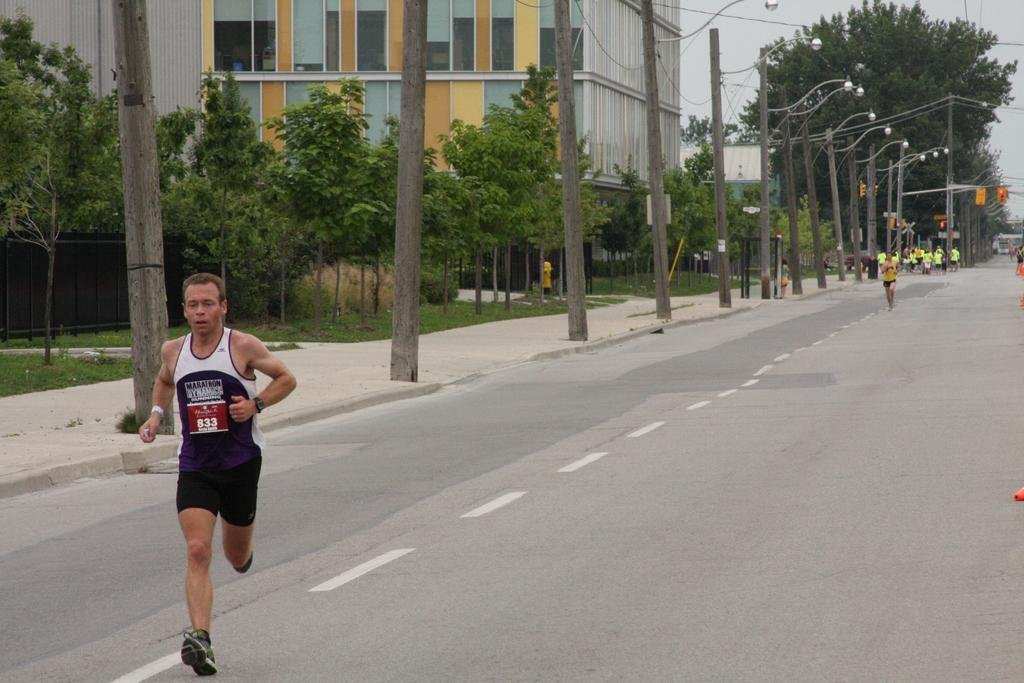What is the man in the image doing? The man is running on the road in the image. Are there any other people engaged in the same activity in the image? Yes, there are people running in the background of the image. What type of natural elements can be seen in the image? Trees are visible in the image. What type of structures are present in the image? Buildings are present in the image. What type of barrier is present in the image? There is a feud (possibly meant to be "fence") in the image. What type of lighting is present on the sidewalk in the image? Pole lights are present on the sidewalk in the image. What is the weather like in the image? The sky is cloudy in the image. What type of garden can be seen in the image? There is no garden present in the image. What type of curtain is hanging in the image? There is no curtain present in the image. 